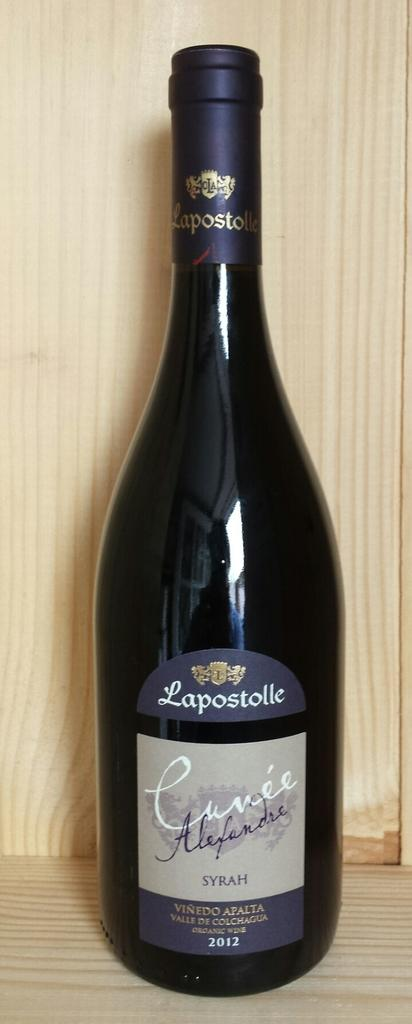<image>
Create a compact narrative representing the image presented. A bottle of Lapostolle Syrah against a wood background. 